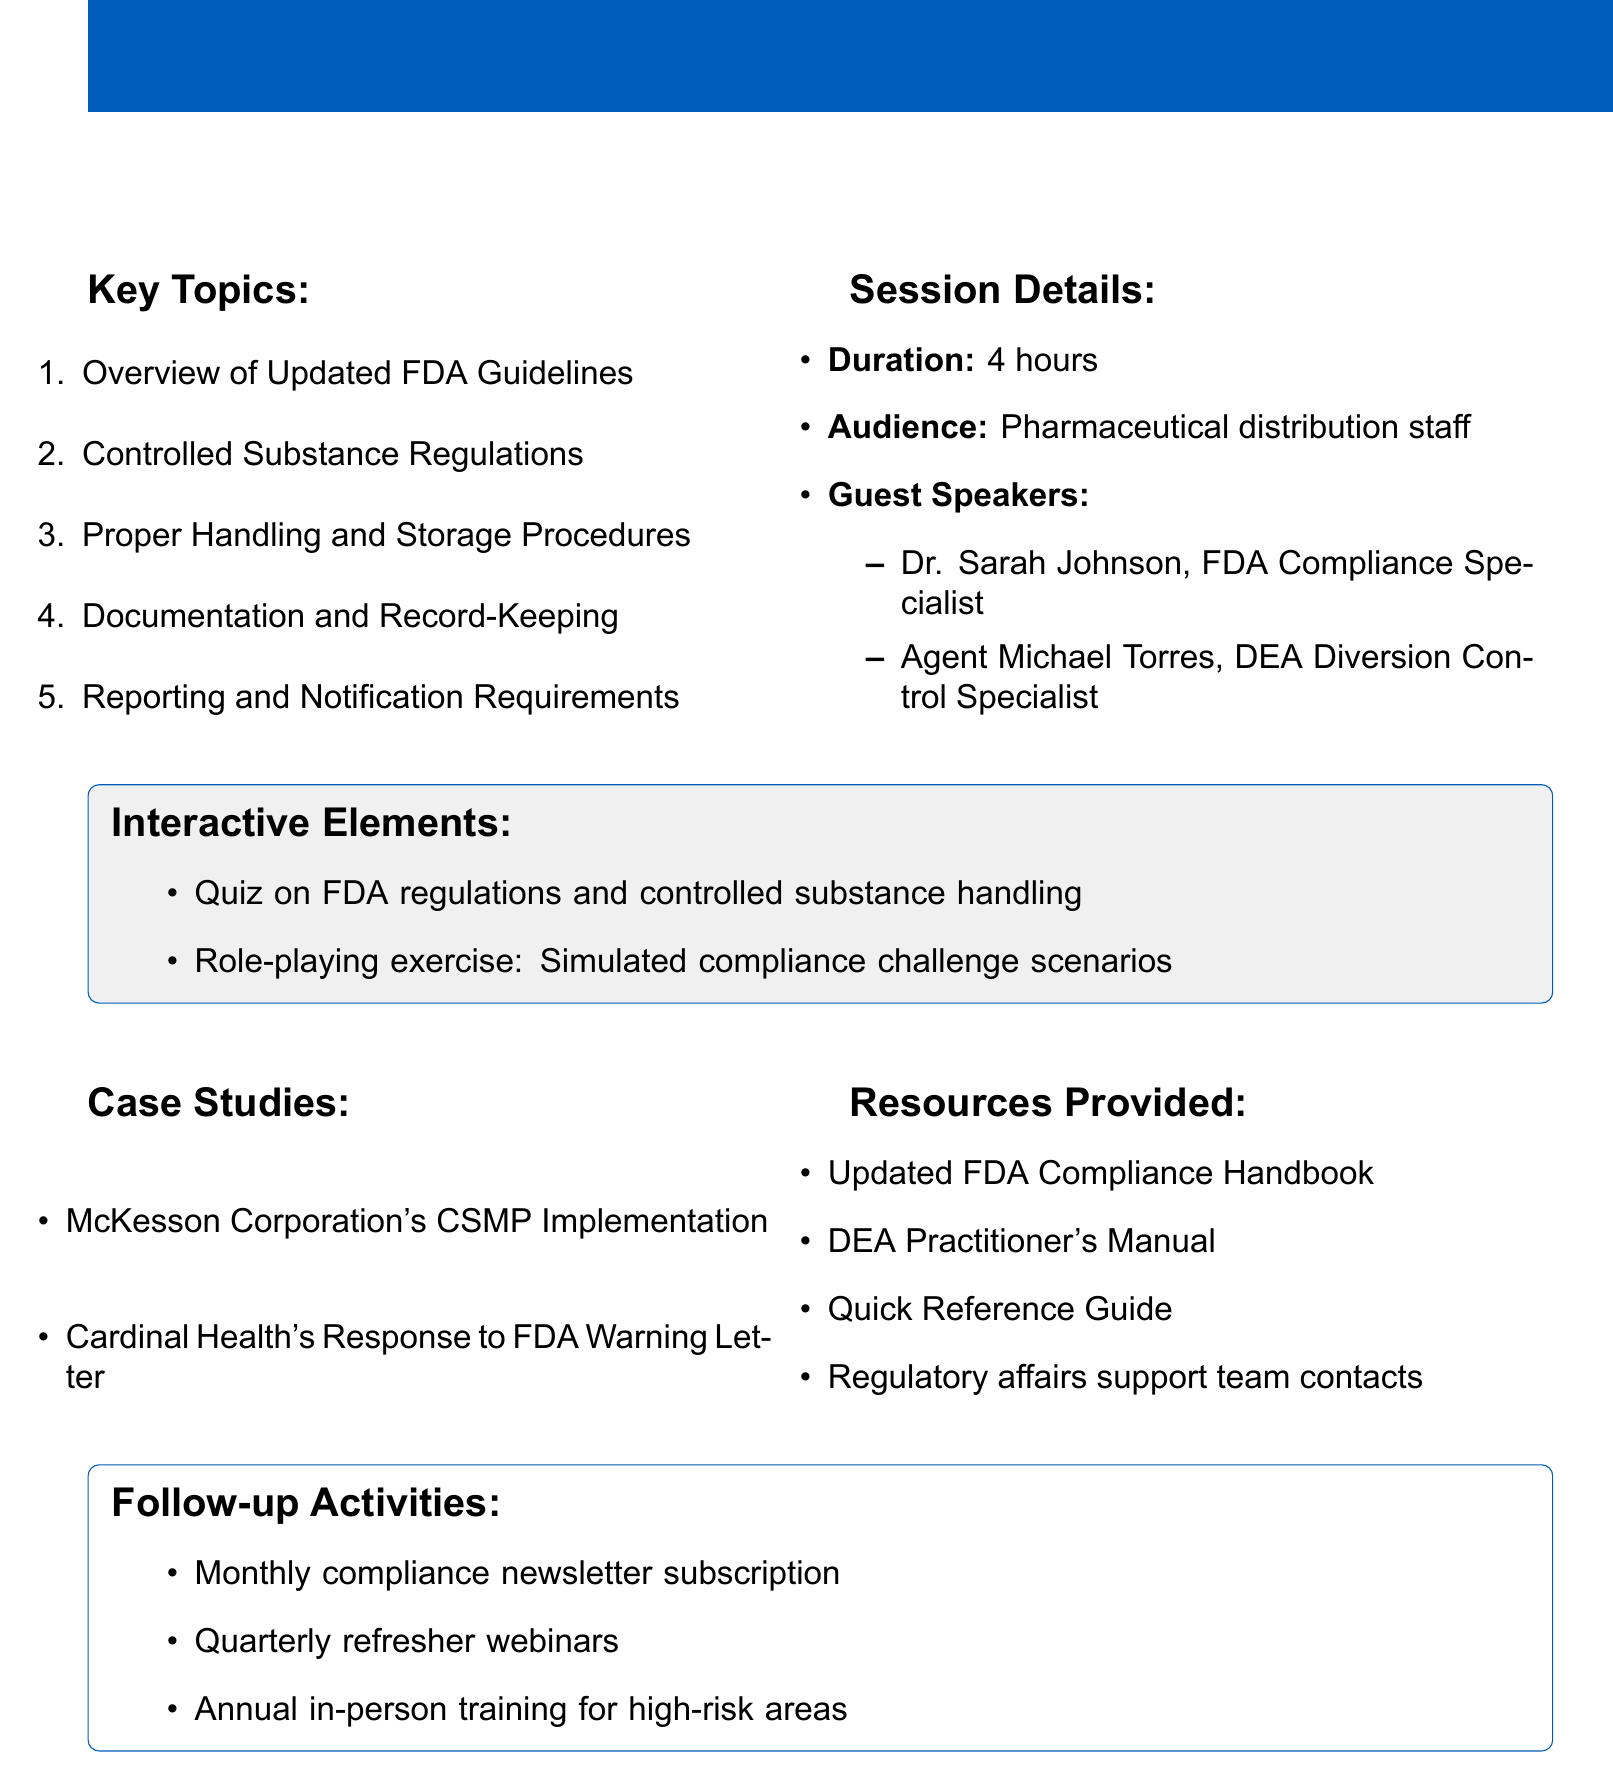what is the title of the session? The title of the session is listed at the beginning of the document, which is about FDA compliance.
Answer: FDA Compliance and Controlled Substance Handling: Regulatory Update for Pharmaceutical Distributors how long is the session? The duration of the session is explicitly mentioned in the document.
Answer: 4 hours who are the guest speakers? The document contains a list of guest speakers with their titles and organizations.
Answer: Dr. Sarah Johnson, Agent Michael Torres what key topic covers storage requirements? One of the key topics discusses specific regulations related to controlled substances, which includes these requirements.
Answer: Controlled Substance Regulations what is the purpose of the interactive quiz? The interactive quiz is designed to assess knowledge regarding specific regulations outlined in the session.
Answer: On FDA regulations and controlled substance handling what case study focuses on compliance improvement? The document lists two case studies, one of which emphasizes corrective actions related to regulatory scrutiny.
Answer: Cardinal Health's Response to FDA Warning Letter what type of resource is provided for controlled substance handling? The document specifies certain resources aimed at helping staff with compliance matters.
Answer: DEA Practitioner's Manual for Controlled Substance Handling what follow-up activity is scheduled monthly? The document outlines several follow-up activities, one of which occurs every month.
Answer: Monthly compliance newsletter subscription 